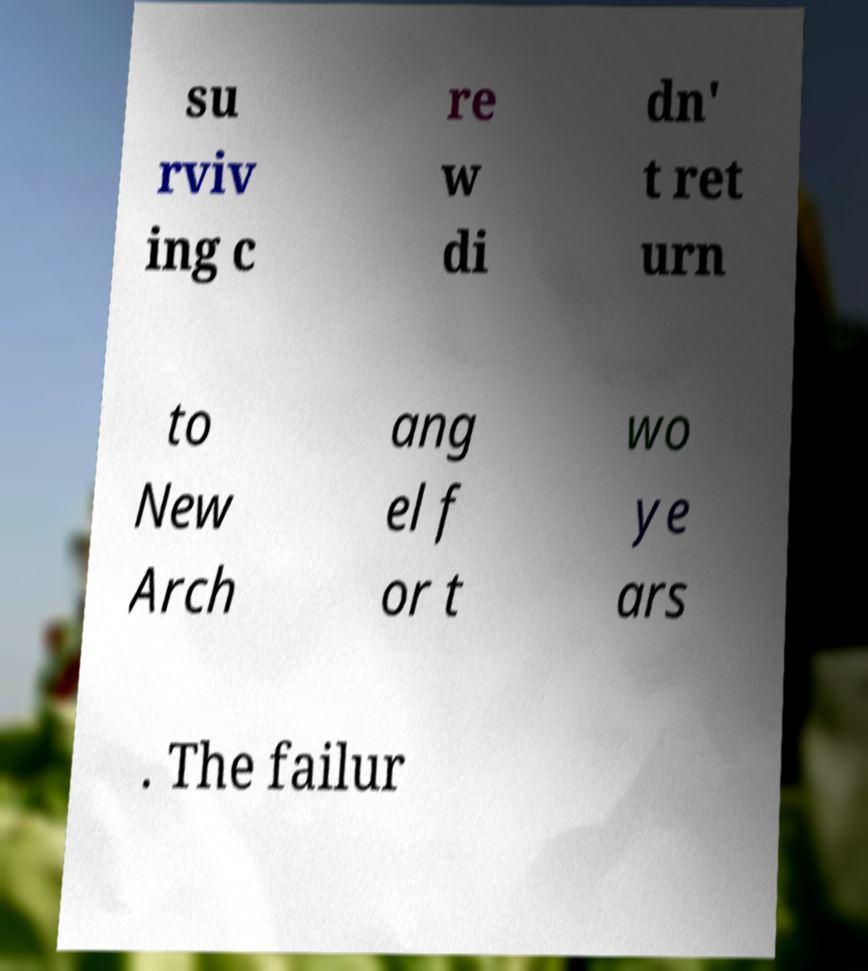For documentation purposes, I need the text within this image transcribed. Could you provide that? su rviv ing c re w di dn' t ret urn to New Arch ang el f or t wo ye ars . The failur 